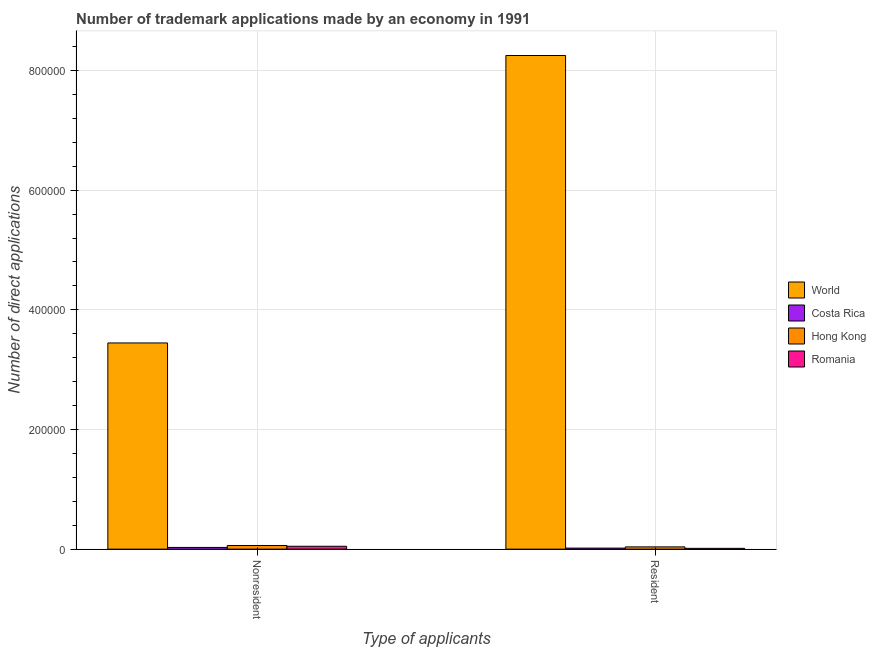How many different coloured bars are there?
Keep it short and to the point. 4. Are the number of bars on each tick of the X-axis equal?
Your answer should be compact. Yes. How many bars are there on the 2nd tick from the right?
Your response must be concise. 4. What is the label of the 2nd group of bars from the left?
Provide a short and direct response. Resident. What is the number of trademark applications made by non residents in Costa Rica?
Your response must be concise. 2870. Across all countries, what is the maximum number of trademark applications made by non residents?
Provide a short and direct response. 3.45e+05. Across all countries, what is the minimum number of trademark applications made by residents?
Provide a succinct answer. 1348. In which country was the number of trademark applications made by residents minimum?
Your answer should be very brief. Romania. What is the total number of trademark applications made by residents in the graph?
Make the answer very short. 8.32e+05. What is the difference between the number of trademark applications made by residents in Romania and that in World?
Provide a short and direct response. -8.24e+05. What is the difference between the number of trademark applications made by non residents in Costa Rica and the number of trademark applications made by residents in Romania?
Your answer should be very brief. 1522. What is the average number of trademark applications made by non residents per country?
Offer a terse response. 8.96e+04. What is the difference between the number of trademark applications made by residents and number of trademark applications made by non residents in Romania?
Your answer should be very brief. -3459. What is the ratio of the number of trademark applications made by non residents in Romania to that in Costa Rica?
Keep it short and to the point. 1.67. Is the number of trademark applications made by residents in Romania less than that in Hong Kong?
Offer a very short reply. Yes. In how many countries, is the number of trademark applications made by residents greater than the average number of trademark applications made by residents taken over all countries?
Your answer should be compact. 1. What does the 3rd bar from the left in Nonresident represents?
Your answer should be very brief. Hong Kong. What does the 4th bar from the right in Nonresident represents?
Give a very brief answer. World. What is the difference between two consecutive major ticks on the Y-axis?
Offer a very short reply. 2.00e+05. Are the values on the major ticks of Y-axis written in scientific E-notation?
Your answer should be compact. No. What is the title of the graph?
Keep it short and to the point. Number of trademark applications made by an economy in 1991. Does "El Salvador" appear as one of the legend labels in the graph?
Ensure brevity in your answer.  No. What is the label or title of the X-axis?
Offer a terse response. Type of applicants. What is the label or title of the Y-axis?
Your answer should be very brief. Number of direct applications. What is the Number of direct applications of World in Nonresident?
Offer a terse response. 3.45e+05. What is the Number of direct applications in Costa Rica in Nonresident?
Give a very brief answer. 2870. What is the Number of direct applications in Hong Kong in Nonresident?
Give a very brief answer. 6122. What is the Number of direct applications of Romania in Nonresident?
Give a very brief answer. 4807. What is the Number of direct applications in World in Resident?
Your response must be concise. 8.25e+05. What is the Number of direct applications in Costa Rica in Resident?
Make the answer very short. 1754. What is the Number of direct applications of Hong Kong in Resident?
Keep it short and to the point. 3778. What is the Number of direct applications in Romania in Resident?
Provide a short and direct response. 1348. Across all Type of applicants, what is the maximum Number of direct applications of World?
Keep it short and to the point. 8.25e+05. Across all Type of applicants, what is the maximum Number of direct applications in Costa Rica?
Your answer should be compact. 2870. Across all Type of applicants, what is the maximum Number of direct applications of Hong Kong?
Make the answer very short. 6122. Across all Type of applicants, what is the maximum Number of direct applications in Romania?
Provide a short and direct response. 4807. Across all Type of applicants, what is the minimum Number of direct applications of World?
Offer a very short reply. 3.45e+05. Across all Type of applicants, what is the minimum Number of direct applications in Costa Rica?
Keep it short and to the point. 1754. Across all Type of applicants, what is the minimum Number of direct applications of Hong Kong?
Your response must be concise. 3778. Across all Type of applicants, what is the minimum Number of direct applications in Romania?
Your response must be concise. 1348. What is the total Number of direct applications in World in the graph?
Offer a terse response. 1.17e+06. What is the total Number of direct applications in Costa Rica in the graph?
Your answer should be very brief. 4624. What is the total Number of direct applications in Hong Kong in the graph?
Make the answer very short. 9900. What is the total Number of direct applications of Romania in the graph?
Provide a short and direct response. 6155. What is the difference between the Number of direct applications of World in Nonresident and that in Resident?
Keep it short and to the point. -4.80e+05. What is the difference between the Number of direct applications of Costa Rica in Nonresident and that in Resident?
Your answer should be very brief. 1116. What is the difference between the Number of direct applications of Hong Kong in Nonresident and that in Resident?
Offer a very short reply. 2344. What is the difference between the Number of direct applications of Romania in Nonresident and that in Resident?
Keep it short and to the point. 3459. What is the difference between the Number of direct applications in World in Nonresident and the Number of direct applications in Costa Rica in Resident?
Give a very brief answer. 3.43e+05. What is the difference between the Number of direct applications in World in Nonresident and the Number of direct applications in Hong Kong in Resident?
Make the answer very short. 3.41e+05. What is the difference between the Number of direct applications of World in Nonresident and the Number of direct applications of Romania in Resident?
Your response must be concise. 3.43e+05. What is the difference between the Number of direct applications in Costa Rica in Nonresident and the Number of direct applications in Hong Kong in Resident?
Your response must be concise. -908. What is the difference between the Number of direct applications of Costa Rica in Nonresident and the Number of direct applications of Romania in Resident?
Offer a terse response. 1522. What is the difference between the Number of direct applications of Hong Kong in Nonresident and the Number of direct applications of Romania in Resident?
Your answer should be compact. 4774. What is the average Number of direct applications in World per Type of applicants?
Offer a terse response. 5.85e+05. What is the average Number of direct applications of Costa Rica per Type of applicants?
Your response must be concise. 2312. What is the average Number of direct applications of Hong Kong per Type of applicants?
Ensure brevity in your answer.  4950. What is the average Number of direct applications of Romania per Type of applicants?
Your response must be concise. 3077.5. What is the difference between the Number of direct applications in World and Number of direct applications in Costa Rica in Nonresident?
Provide a succinct answer. 3.42e+05. What is the difference between the Number of direct applications in World and Number of direct applications in Hong Kong in Nonresident?
Provide a succinct answer. 3.39e+05. What is the difference between the Number of direct applications of World and Number of direct applications of Romania in Nonresident?
Give a very brief answer. 3.40e+05. What is the difference between the Number of direct applications of Costa Rica and Number of direct applications of Hong Kong in Nonresident?
Offer a terse response. -3252. What is the difference between the Number of direct applications in Costa Rica and Number of direct applications in Romania in Nonresident?
Provide a succinct answer. -1937. What is the difference between the Number of direct applications of Hong Kong and Number of direct applications of Romania in Nonresident?
Your response must be concise. 1315. What is the difference between the Number of direct applications of World and Number of direct applications of Costa Rica in Resident?
Provide a succinct answer. 8.23e+05. What is the difference between the Number of direct applications of World and Number of direct applications of Hong Kong in Resident?
Keep it short and to the point. 8.21e+05. What is the difference between the Number of direct applications in World and Number of direct applications in Romania in Resident?
Give a very brief answer. 8.24e+05. What is the difference between the Number of direct applications of Costa Rica and Number of direct applications of Hong Kong in Resident?
Offer a very short reply. -2024. What is the difference between the Number of direct applications in Costa Rica and Number of direct applications in Romania in Resident?
Provide a short and direct response. 406. What is the difference between the Number of direct applications of Hong Kong and Number of direct applications of Romania in Resident?
Provide a succinct answer. 2430. What is the ratio of the Number of direct applications of World in Nonresident to that in Resident?
Your answer should be very brief. 0.42. What is the ratio of the Number of direct applications of Costa Rica in Nonresident to that in Resident?
Provide a succinct answer. 1.64. What is the ratio of the Number of direct applications of Hong Kong in Nonresident to that in Resident?
Your response must be concise. 1.62. What is the ratio of the Number of direct applications of Romania in Nonresident to that in Resident?
Give a very brief answer. 3.57. What is the difference between the highest and the second highest Number of direct applications of World?
Ensure brevity in your answer.  4.80e+05. What is the difference between the highest and the second highest Number of direct applications of Costa Rica?
Give a very brief answer. 1116. What is the difference between the highest and the second highest Number of direct applications in Hong Kong?
Your response must be concise. 2344. What is the difference between the highest and the second highest Number of direct applications of Romania?
Provide a succinct answer. 3459. What is the difference between the highest and the lowest Number of direct applications of World?
Your answer should be very brief. 4.80e+05. What is the difference between the highest and the lowest Number of direct applications in Costa Rica?
Provide a succinct answer. 1116. What is the difference between the highest and the lowest Number of direct applications of Hong Kong?
Your answer should be very brief. 2344. What is the difference between the highest and the lowest Number of direct applications of Romania?
Your answer should be very brief. 3459. 